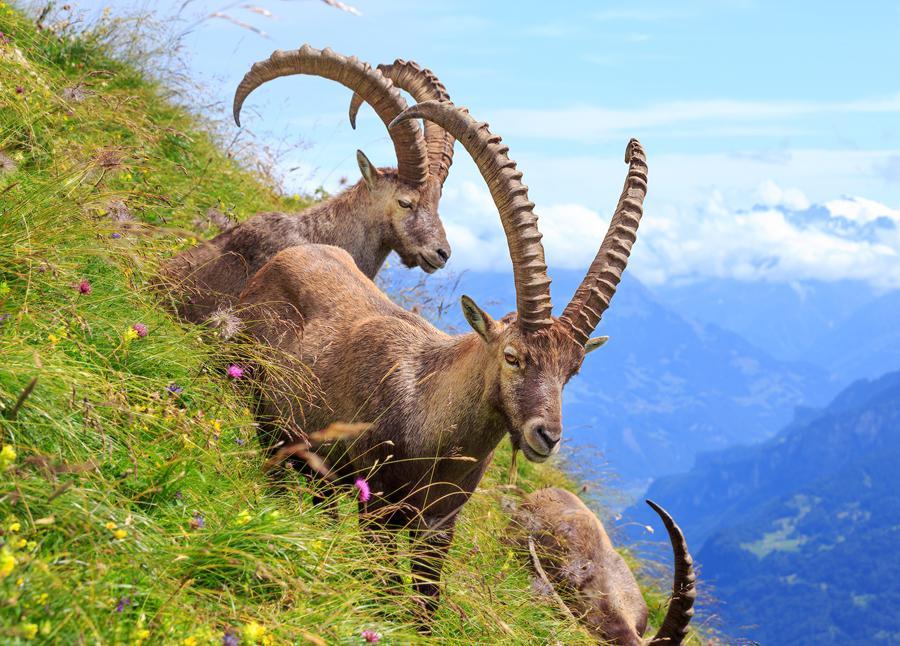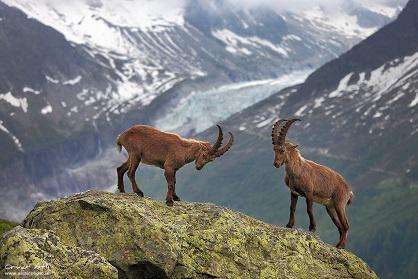The first image is the image on the left, the second image is the image on the right. Examine the images to the left and right. Is the description "Two rams are facing each other on top of a boulder in the mountains in one image." accurate? Answer yes or no. Yes. The first image is the image on the left, the second image is the image on the right. Assess this claim about the two images: "In at least one image there is a lone Ibex on rocky ground". Correct or not? Answer yes or no. No. 